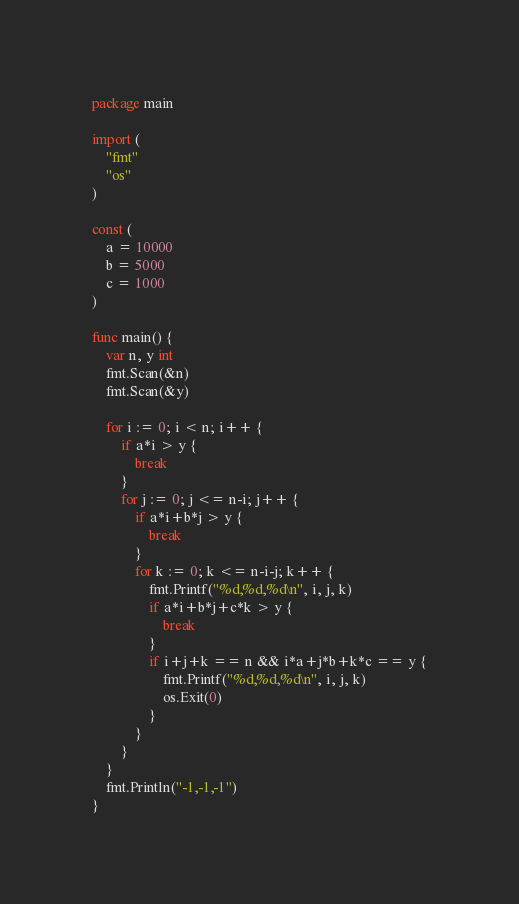Convert code to text. <code><loc_0><loc_0><loc_500><loc_500><_Go_>package main

import (
	"fmt"
	"os"
)

const (
	a = 10000
	b = 5000
	c = 1000
)

func main() {
	var n, y int
	fmt.Scan(&n)
	fmt.Scan(&y)

	for i := 0; i < n; i++ {
		if a*i > y {
			break
		}
		for j := 0; j <= n-i; j++ {
			if a*i+b*j > y {
				break
			}
			for k := 0; k <= n-i-j; k++ {
				fmt.Printf("%d,%d,%d\n", i, j, k)
				if a*i+b*j+c*k > y {
					break
				}
				if i+j+k == n && i*a+j*b+k*c == y {
					fmt.Printf("%d,%d,%d\n", i, j, k)
					os.Exit(0)
				}
			}
		}
	}
	fmt.Println("-1,-1,-1")
}
</code> 